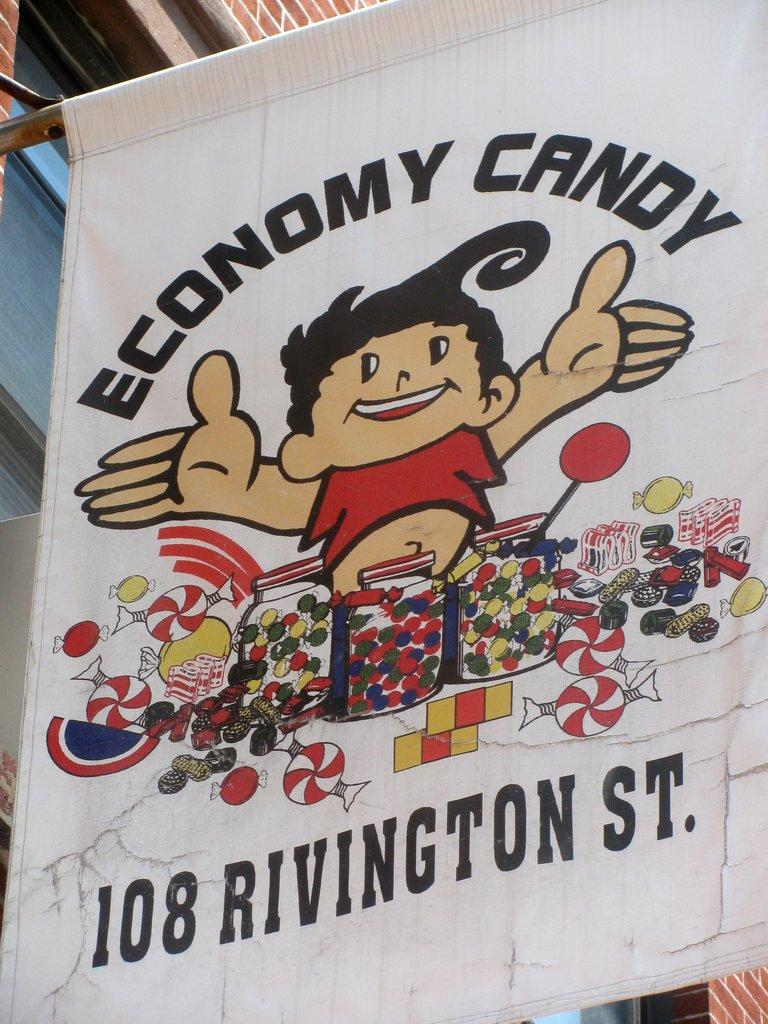What is hanging or displayed in the image? There is a banner in the image. What type of structure can be seen in the image? There is a building in the image. What kind of character is present in the image? An animated person is present in the image. How many objects can be identified in the image? There are many objects in the image. What is written or printed on the banner? There is text printed on the banner. What architectural feature can be seen on the building? There are windows in the image. Can you see any slaves in the image? There is no mention or indication of any slaves in the image. What type of tank is visible in the image? There is no tank present in the image. 